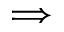Convert formula to latex. <formula><loc_0><loc_0><loc_500><loc_500>\Longrightarrow</formula> 